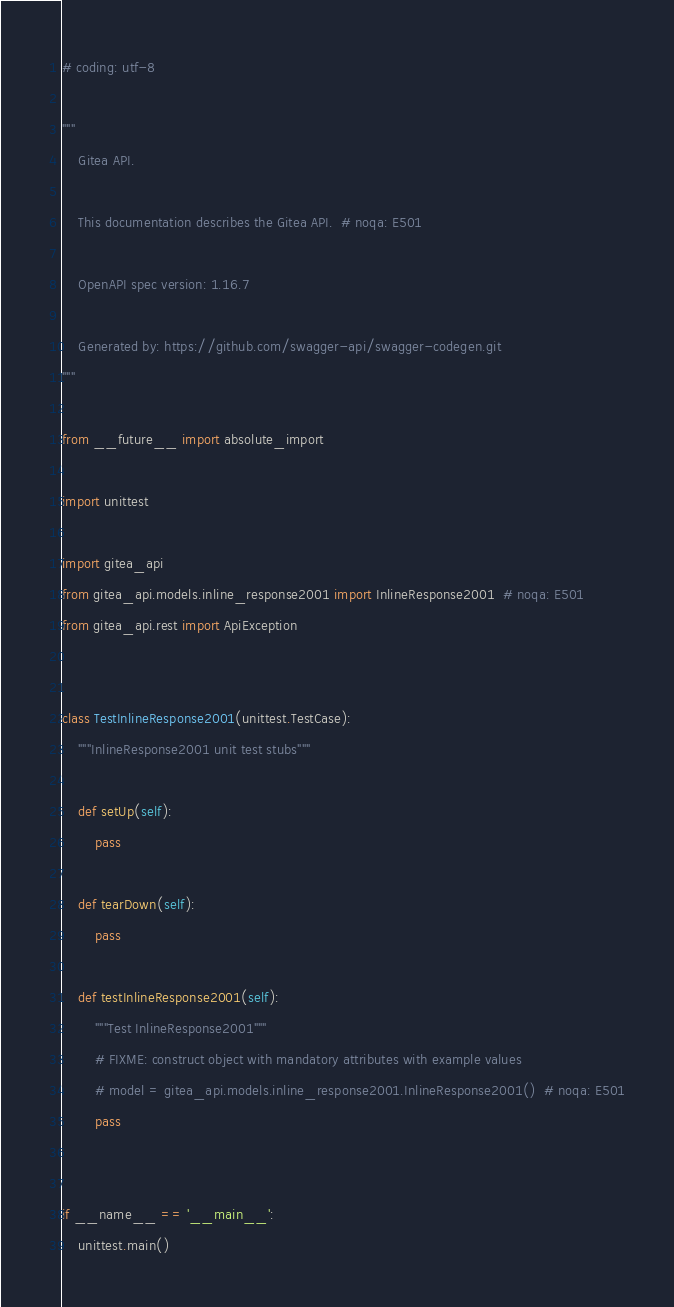<code> <loc_0><loc_0><loc_500><loc_500><_Python_># coding: utf-8

"""
    Gitea API.

    This documentation describes the Gitea API.  # noqa: E501

    OpenAPI spec version: 1.16.7
    
    Generated by: https://github.com/swagger-api/swagger-codegen.git
"""

from __future__ import absolute_import

import unittest

import gitea_api
from gitea_api.models.inline_response2001 import InlineResponse2001  # noqa: E501
from gitea_api.rest import ApiException


class TestInlineResponse2001(unittest.TestCase):
    """InlineResponse2001 unit test stubs"""

    def setUp(self):
        pass

    def tearDown(self):
        pass

    def testInlineResponse2001(self):
        """Test InlineResponse2001"""
        # FIXME: construct object with mandatory attributes with example values
        # model = gitea_api.models.inline_response2001.InlineResponse2001()  # noqa: E501
        pass


if __name__ == '__main__':
    unittest.main()
</code> 